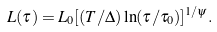<formula> <loc_0><loc_0><loc_500><loc_500>L ( \tau ) = L _ { 0 } [ ( T / \Delta ) \ln ( \tau / \tau _ { 0 } ) ] ^ { 1 / \psi } .</formula> 